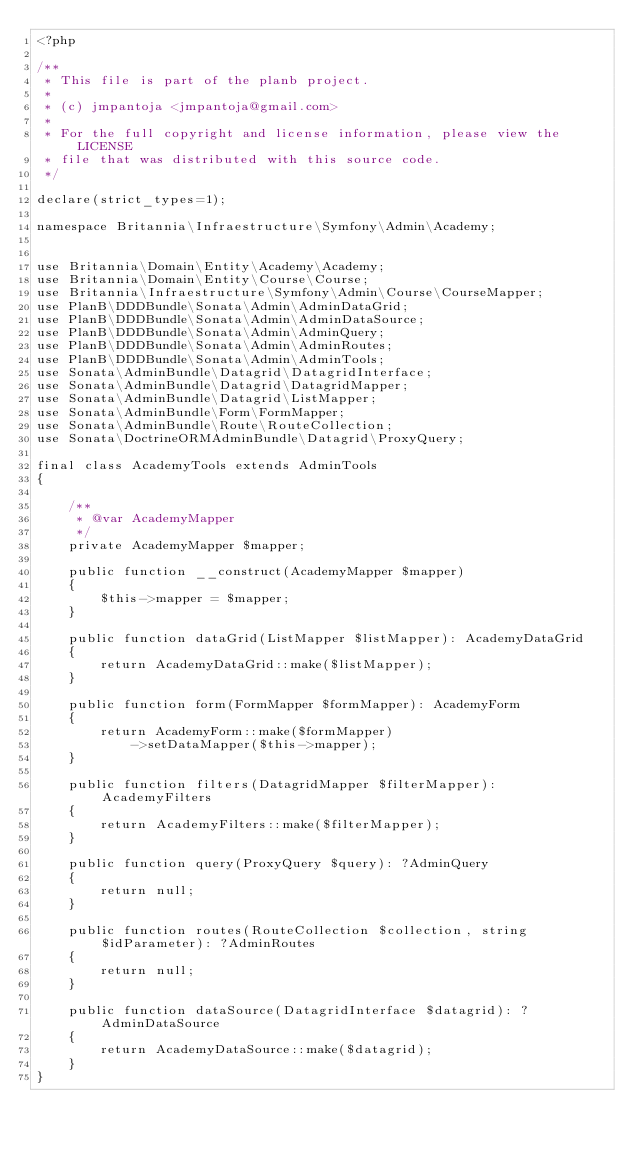<code> <loc_0><loc_0><loc_500><loc_500><_PHP_><?php

/**
 * This file is part of the planb project.
 *
 * (c) jmpantoja <jmpantoja@gmail.com>
 *
 * For the full copyright and license information, please view the LICENSE
 * file that was distributed with this source code.
 */

declare(strict_types=1);

namespace Britannia\Infraestructure\Symfony\Admin\Academy;


use Britannia\Domain\Entity\Academy\Academy;
use Britannia\Domain\Entity\Course\Course;
use Britannia\Infraestructure\Symfony\Admin\Course\CourseMapper;
use PlanB\DDDBundle\Sonata\Admin\AdminDataGrid;
use PlanB\DDDBundle\Sonata\Admin\AdminDataSource;
use PlanB\DDDBundle\Sonata\Admin\AdminQuery;
use PlanB\DDDBundle\Sonata\Admin\AdminRoutes;
use PlanB\DDDBundle\Sonata\Admin\AdminTools;
use Sonata\AdminBundle\Datagrid\DatagridInterface;
use Sonata\AdminBundle\Datagrid\DatagridMapper;
use Sonata\AdminBundle\Datagrid\ListMapper;
use Sonata\AdminBundle\Form\FormMapper;
use Sonata\AdminBundle\Route\RouteCollection;
use Sonata\DoctrineORMAdminBundle\Datagrid\ProxyQuery;

final class AcademyTools extends AdminTools
{

    /**
     * @var AcademyMapper
     */
    private AcademyMapper $mapper;

    public function __construct(AcademyMapper $mapper)
    {
        $this->mapper = $mapper;
    }

    public function dataGrid(ListMapper $listMapper): AcademyDataGrid
    {
        return AcademyDataGrid::make($listMapper);
    }

    public function form(FormMapper $formMapper): AcademyForm
    {
        return AcademyForm::make($formMapper)
            ->setDataMapper($this->mapper);
    }

    public function filters(DatagridMapper $filterMapper): AcademyFilters
    {
        return AcademyFilters::make($filterMapper);
    }

    public function query(ProxyQuery $query): ?AdminQuery
    {
        return null;
    }

    public function routes(RouteCollection $collection, string $idParameter): ?AdminRoutes
    {
        return null;
    }

    public function dataSource(DatagridInterface $datagrid): ?AdminDataSource
    {
        return AcademyDataSource::make($datagrid);
    }
}
</code> 